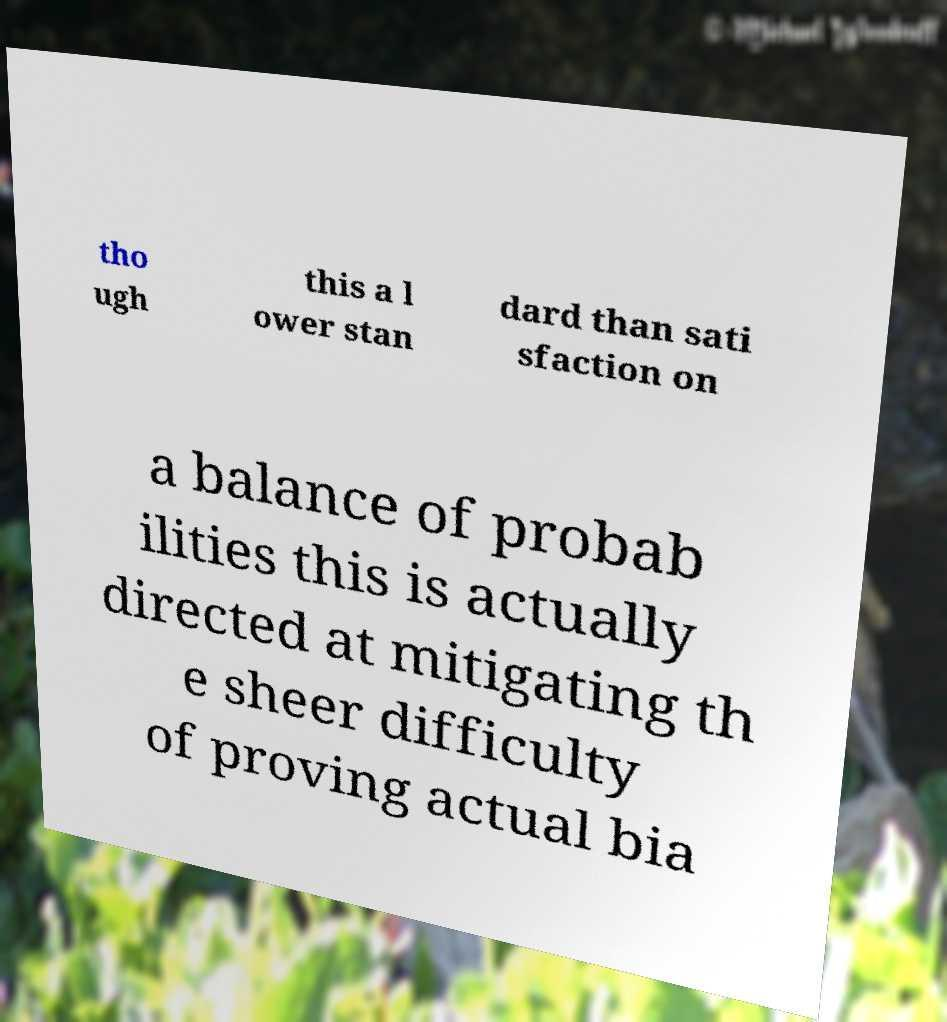Please identify and transcribe the text found in this image. tho ugh this a l ower stan dard than sati sfaction on a balance of probab ilities this is actually directed at mitigating th e sheer difficulty of proving actual bia 